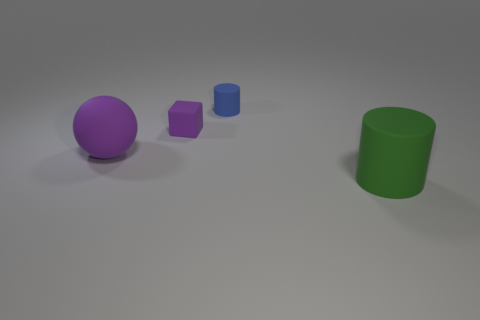What number of things are either big purple objects or big green rubber cylinders?
Ensure brevity in your answer.  2. What number of other things are there of the same color as the large cylinder?
Keep it short and to the point. 0. The purple object that is the same size as the green cylinder is what shape?
Offer a terse response. Sphere. The tiny rubber thing to the left of the small blue thing is what color?
Your answer should be very brief. Purple. What number of things are matte objects that are in front of the large sphere or rubber cylinders on the right side of the tiny blue cylinder?
Ensure brevity in your answer.  1. Is the purple cube the same size as the purple sphere?
Keep it short and to the point. No. How many spheres are either tiny blue objects or large green things?
Ensure brevity in your answer.  0. What number of big objects are both right of the tiny purple rubber thing and left of the tiny blue matte cylinder?
Your answer should be very brief. 0. There is a purple sphere; is its size the same as the purple object that is on the right side of the big purple thing?
Offer a very short reply. No. There is a purple matte thing that is in front of the purple rubber object that is on the right side of the big purple thing; is there a green cylinder that is behind it?
Your response must be concise. No. 